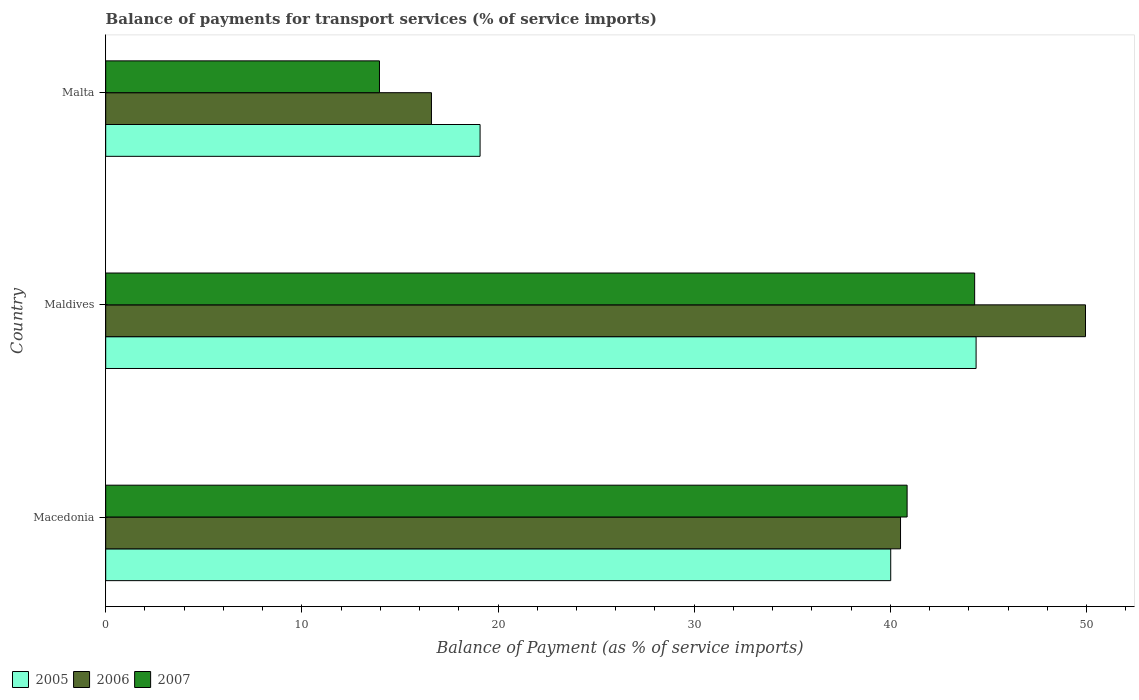Are the number of bars on each tick of the Y-axis equal?
Your answer should be compact. Yes. How many bars are there on the 2nd tick from the bottom?
Your answer should be compact. 3. What is the label of the 3rd group of bars from the top?
Your response must be concise. Macedonia. In how many cases, is the number of bars for a given country not equal to the number of legend labels?
Provide a short and direct response. 0. What is the balance of payments for transport services in 2006 in Malta?
Provide a short and direct response. 16.61. Across all countries, what is the maximum balance of payments for transport services in 2007?
Ensure brevity in your answer.  44.29. Across all countries, what is the minimum balance of payments for transport services in 2006?
Provide a succinct answer. 16.61. In which country was the balance of payments for transport services in 2005 maximum?
Give a very brief answer. Maldives. In which country was the balance of payments for transport services in 2007 minimum?
Offer a very short reply. Malta. What is the total balance of payments for transport services in 2005 in the graph?
Ensure brevity in your answer.  103.47. What is the difference between the balance of payments for transport services in 2007 in Macedonia and that in Malta?
Provide a short and direct response. 26.9. What is the difference between the balance of payments for transport services in 2005 in Maldives and the balance of payments for transport services in 2007 in Macedonia?
Offer a terse response. 3.52. What is the average balance of payments for transport services in 2005 per country?
Provide a short and direct response. 34.49. What is the difference between the balance of payments for transport services in 2007 and balance of payments for transport services in 2005 in Maldives?
Provide a succinct answer. -0.07. In how many countries, is the balance of payments for transport services in 2006 greater than 44 %?
Give a very brief answer. 1. What is the ratio of the balance of payments for transport services in 2005 in Macedonia to that in Maldives?
Your response must be concise. 0.9. Is the balance of payments for transport services in 2007 in Maldives less than that in Malta?
Your response must be concise. No. What is the difference between the highest and the second highest balance of payments for transport services in 2007?
Give a very brief answer. 3.44. What is the difference between the highest and the lowest balance of payments for transport services in 2005?
Your answer should be very brief. 25.28. In how many countries, is the balance of payments for transport services in 2006 greater than the average balance of payments for transport services in 2006 taken over all countries?
Make the answer very short. 2. Is the sum of the balance of payments for transport services in 2007 in Maldives and Malta greater than the maximum balance of payments for transport services in 2005 across all countries?
Your answer should be compact. Yes. What does the 2nd bar from the bottom in Malta represents?
Ensure brevity in your answer.  2006. How many bars are there?
Your answer should be very brief. 9. How many countries are there in the graph?
Your answer should be very brief. 3. What is the difference between two consecutive major ticks on the X-axis?
Your response must be concise. 10. Are the values on the major ticks of X-axis written in scientific E-notation?
Offer a terse response. No. Does the graph contain any zero values?
Your answer should be compact. No. Where does the legend appear in the graph?
Offer a terse response. Bottom left. How many legend labels are there?
Make the answer very short. 3. What is the title of the graph?
Provide a succinct answer. Balance of payments for transport services (% of service imports). Does "1981" appear as one of the legend labels in the graph?
Your response must be concise. No. What is the label or title of the X-axis?
Your answer should be very brief. Balance of Payment (as % of service imports). What is the Balance of Payment (as % of service imports) of 2005 in Macedonia?
Give a very brief answer. 40.02. What is the Balance of Payment (as % of service imports) of 2006 in Macedonia?
Offer a very short reply. 40.52. What is the Balance of Payment (as % of service imports) of 2007 in Macedonia?
Offer a very short reply. 40.85. What is the Balance of Payment (as % of service imports) in 2005 in Maldives?
Your answer should be compact. 44.37. What is the Balance of Payment (as % of service imports) in 2006 in Maldives?
Ensure brevity in your answer.  49.95. What is the Balance of Payment (as % of service imports) in 2007 in Maldives?
Keep it short and to the point. 44.29. What is the Balance of Payment (as % of service imports) in 2005 in Malta?
Keep it short and to the point. 19.08. What is the Balance of Payment (as % of service imports) of 2006 in Malta?
Give a very brief answer. 16.61. What is the Balance of Payment (as % of service imports) in 2007 in Malta?
Offer a very short reply. 13.96. Across all countries, what is the maximum Balance of Payment (as % of service imports) in 2005?
Your response must be concise. 44.37. Across all countries, what is the maximum Balance of Payment (as % of service imports) in 2006?
Your response must be concise. 49.95. Across all countries, what is the maximum Balance of Payment (as % of service imports) of 2007?
Offer a terse response. 44.29. Across all countries, what is the minimum Balance of Payment (as % of service imports) of 2005?
Keep it short and to the point. 19.08. Across all countries, what is the minimum Balance of Payment (as % of service imports) of 2006?
Offer a very short reply. 16.61. Across all countries, what is the minimum Balance of Payment (as % of service imports) of 2007?
Your answer should be very brief. 13.96. What is the total Balance of Payment (as % of service imports) of 2005 in the graph?
Give a very brief answer. 103.47. What is the total Balance of Payment (as % of service imports) in 2006 in the graph?
Give a very brief answer. 107.07. What is the total Balance of Payment (as % of service imports) of 2007 in the graph?
Provide a short and direct response. 99.1. What is the difference between the Balance of Payment (as % of service imports) of 2005 in Macedonia and that in Maldives?
Provide a succinct answer. -4.35. What is the difference between the Balance of Payment (as % of service imports) of 2006 in Macedonia and that in Maldives?
Provide a succinct answer. -9.43. What is the difference between the Balance of Payment (as % of service imports) of 2007 in Macedonia and that in Maldives?
Your answer should be compact. -3.44. What is the difference between the Balance of Payment (as % of service imports) in 2005 in Macedonia and that in Malta?
Give a very brief answer. 20.93. What is the difference between the Balance of Payment (as % of service imports) of 2006 in Macedonia and that in Malta?
Your response must be concise. 23.91. What is the difference between the Balance of Payment (as % of service imports) in 2007 in Macedonia and that in Malta?
Your response must be concise. 26.9. What is the difference between the Balance of Payment (as % of service imports) in 2005 in Maldives and that in Malta?
Your response must be concise. 25.28. What is the difference between the Balance of Payment (as % of service imports) of 2006 in Maldives and that in Malta?
Make the answer very short. 33.34. What is the difference between the Balance of Payment (as % of service imports) in 2007 in Maldives and that in Malta?
Offer a very short reply. 30.34. What is the difference between the Balance of Payment (as % of service imports) in 2005 in Macedonia and the Balance of Payment (as % of service imports) in 2006 in Maldives?
Make the answer very short. -9.93. What is the difference between the Balance of Payment (as % of service imports) in 2005 in Macedonia and the Balance of Payment (as % of service imports) in 2007 in Maldives?
Keep it short and to the point. -4.28. What is the difference between the Balance of Payment (as % of service imports) of 2006 in Macedonia and the Balance of Payment (as % of service imports) of 2007 in Maldives?
Offer a terse response. -3.78. What is the difference between the Balance of Payment (as % of service imports) in 2005 in Macedonia and the Balance of Payment (as % of service imports) in 2006 in Malta?
Offer a terse response. 23.41. What is the difference between the Balance of Payment (as % of service imports) of 2005 in Macedonia and the Balance of Payment (as % of service imports) of 2007 in Malta?
Make the answer very short. 26.06. What is the difference between the Balance of Payment (as % of service imports) of 2006 in Macedonia and the Balance of Payment (as % of service imports) of 2007 in Malta?
Your response must be concise. 26.56. What is the difference between the Balance of Payment (as % of service imports) in 2005 in Maldives and the Balance of Payment (as % of service imports) in 2006 in Malta?
Offer a terse response. 27.76. What is the difference between the Balance of Payment (as % of service imports) of 2005 in Maldives and the Balance of Payment (as % of service imports) of 2007 in Malta?
Keep it short and to the point. 30.41. What is the difference between the Balance of Payment (as % of service imports) of 2006 in Maldives and the Balance of Payment (as % of service imports) of 2007 in Malta?
Offer a very short reply. 35.99. What is the average Balance of Payment (as % of service imports) of 2005 per country?
Your response must be concise. 34.49. What is the average Balance of Payment (as % of service imports) of 2006 per country?
Offer a terse response. 35.69. What is the average Balance of Payment (as % of service imports) of 2007 per country?
Keep it short and to the point. 33.03. What is the difference between the Balance of Payment (as % of service imports) in 2005 and Balance of Payment (as % of service imports) in 2006 in Macedonia?
Make the answer very short. -0.5. What is the difference between the Balance of Payment (as % of service imports) of 2005 and Balance of Payment (as % of service imports) of 2007 in Macedonia?
Offer a very short reply. -0.84. What is the difference between the Balance of Payment (as % of service imports) in 2006 and Balance of Payment (as % of service imports) in 2007 in Macedonia?
Provide a succinct answer. -0.34. What is the difference between the Balance of Payment (as % of service imports) of 2005 and Balance of Payment (as % of service imports) of 2006 in Maldives?
Keep it short and to the point. -5.58. What is the difference between the Balance of Payment (as % of service imports) of 2005 and Balance of Payment (as % of service imports) of 2007 in Maldives?
Provide a short and direct response. 0.07. What is the difference between the Balance of Payment (as % of service imports) of 2006 and Balance of Payment (as % of service imports) of 2007 in Maldives?
Ensure brevity in your answer.  5.65. What is the difference between the Balance of Payment (as % of service imports) in 2005 and Balance of Payment (as % of service imports) in 2006 in Malta?
Provide a short and direct response. 2.48. What is the difference between the Balance of Payment (as % of service imports) in 2005 and Balance of Payment (as % of service imports) in 2007 in Malta?
Your answer should be compact. 5.13. What is the difference between the Balance of Payment (as % of service imports) in 2006 and Balance of Payment (as % of service imports) in 2007 in Malta?
Your response must be concise. 2.65. What is the ratio of the Balance of Payment (as % of service imports) of 2005 in Macedonia to that in Maldives?
Keep it short and to the point. 0.9. What is the ratio of the Balance of Payment (as % of service imports) in 2006 in Macedonia to that in Maldives?
Ensure brevity in your answer.  0.81. What is the ratio of the Balance of Payment (as % of service imports) of 2007 in Macedonia to that in Maldives?
Ensure brevity in your answer.  0.92. What is the ratio of the Balance of Payment (as % of service imports) of 2005 in Macedonia to that in Malta?
Provide a succinct answer. 2.1. What is the ratio of the Balance of Payment (as % of service imports) in 2006 in Macedonia to that in Malta?
Ensure brevity in your answer.  2.44. What is the ratio of the Balance of Payment (as % of service imports) in 2007 in Macedonia to that in Malta?
Provide a short and direct response. 2.93. What is the ratio of the Balance of Payment (as % of service imports) in 2005 in Maldives to that in Malta?
Your answer should be compact. 2.32. What is the ratio of the Balance of Payment (as % of service imports) in 2006 in Maldives to that in Malta?
Offer a very short reply. 3.01. What is the ratio of the Balance of Payment (as % of service imports) in 2007 in Maldives to that in Malta?
Make the answer very short. 3.17. What is the difference between the highest and the second highest Balance of Payment (as % of service imports) in 2005?
Your response must be concise. 4.35. What is the difference between the highest and the second highest Balance of Payment (as % of service imports) of 2006?
Give a very brief answer. 9.43. What is the difference between the highest and the second highest Balance of Payment (as % of service imports) in 2007?
Offer a terse response. 3.44. What is the difference between the highest and the lowest Balance of Payment (as % of service imports) in 2005?
Keep it short and to the point. 25.28. What is the difference between the highest and the lowest Balance of Payment (as % of service imports) in 2006?
Your answer should be very brief. 33.34. What is the difference between the highest and the lowest Balance of Payment (as % of service imports) of 2007?
Your answer should be compact. 30.34. 